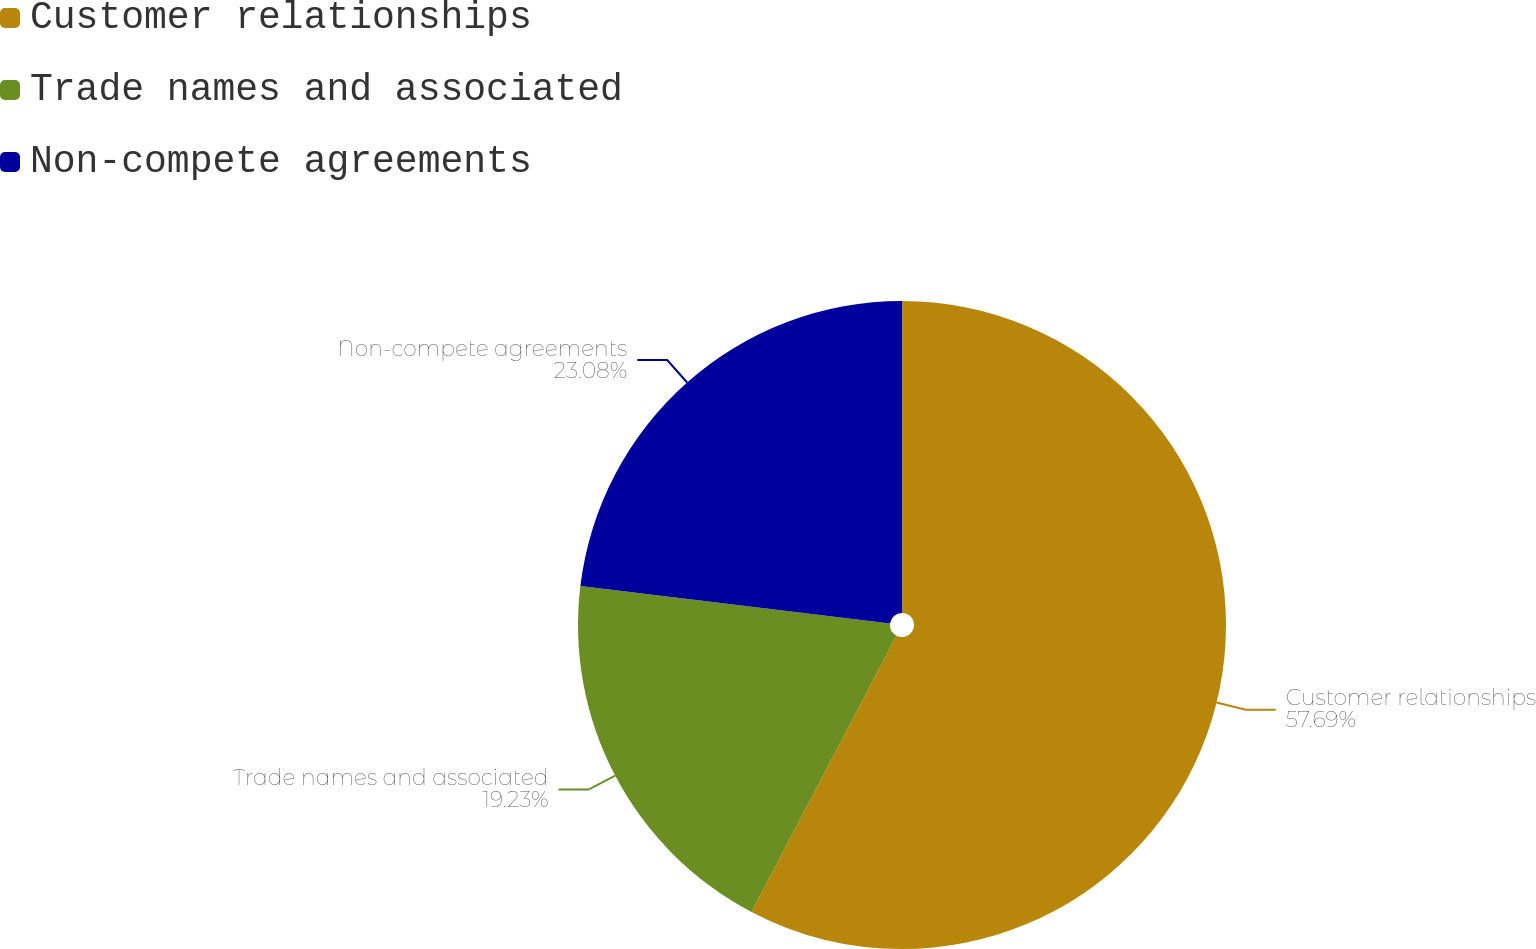Convert chart. <chart><loc_0><loc_0><loc_500><loc_500><pie_chart><fcel>Customer relationships<fcel>Trade names and associated<fcel>Non-compete agreements<nl><fcel>57.69%<fcel>19.23%<fcel>23.08%<nl></chart> 